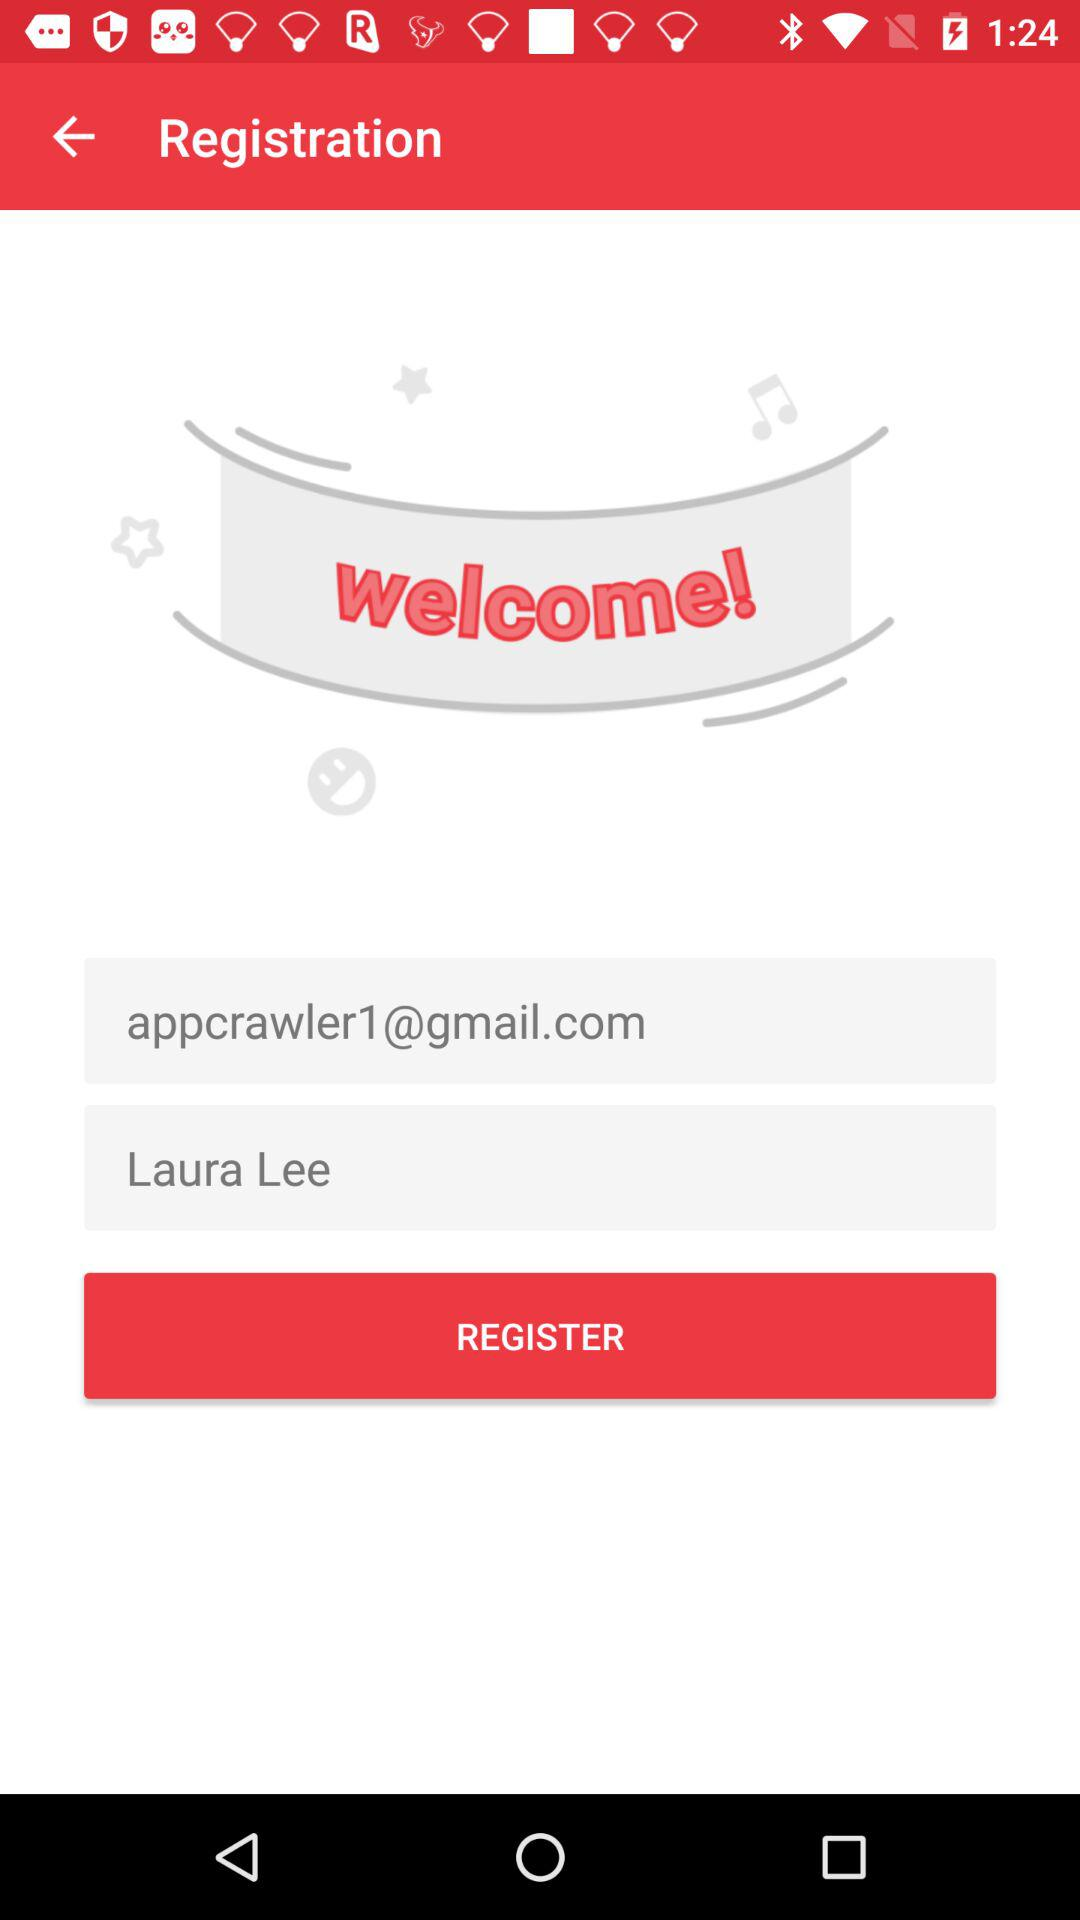What is the name of the user? The name of the user is Laura Lee. 